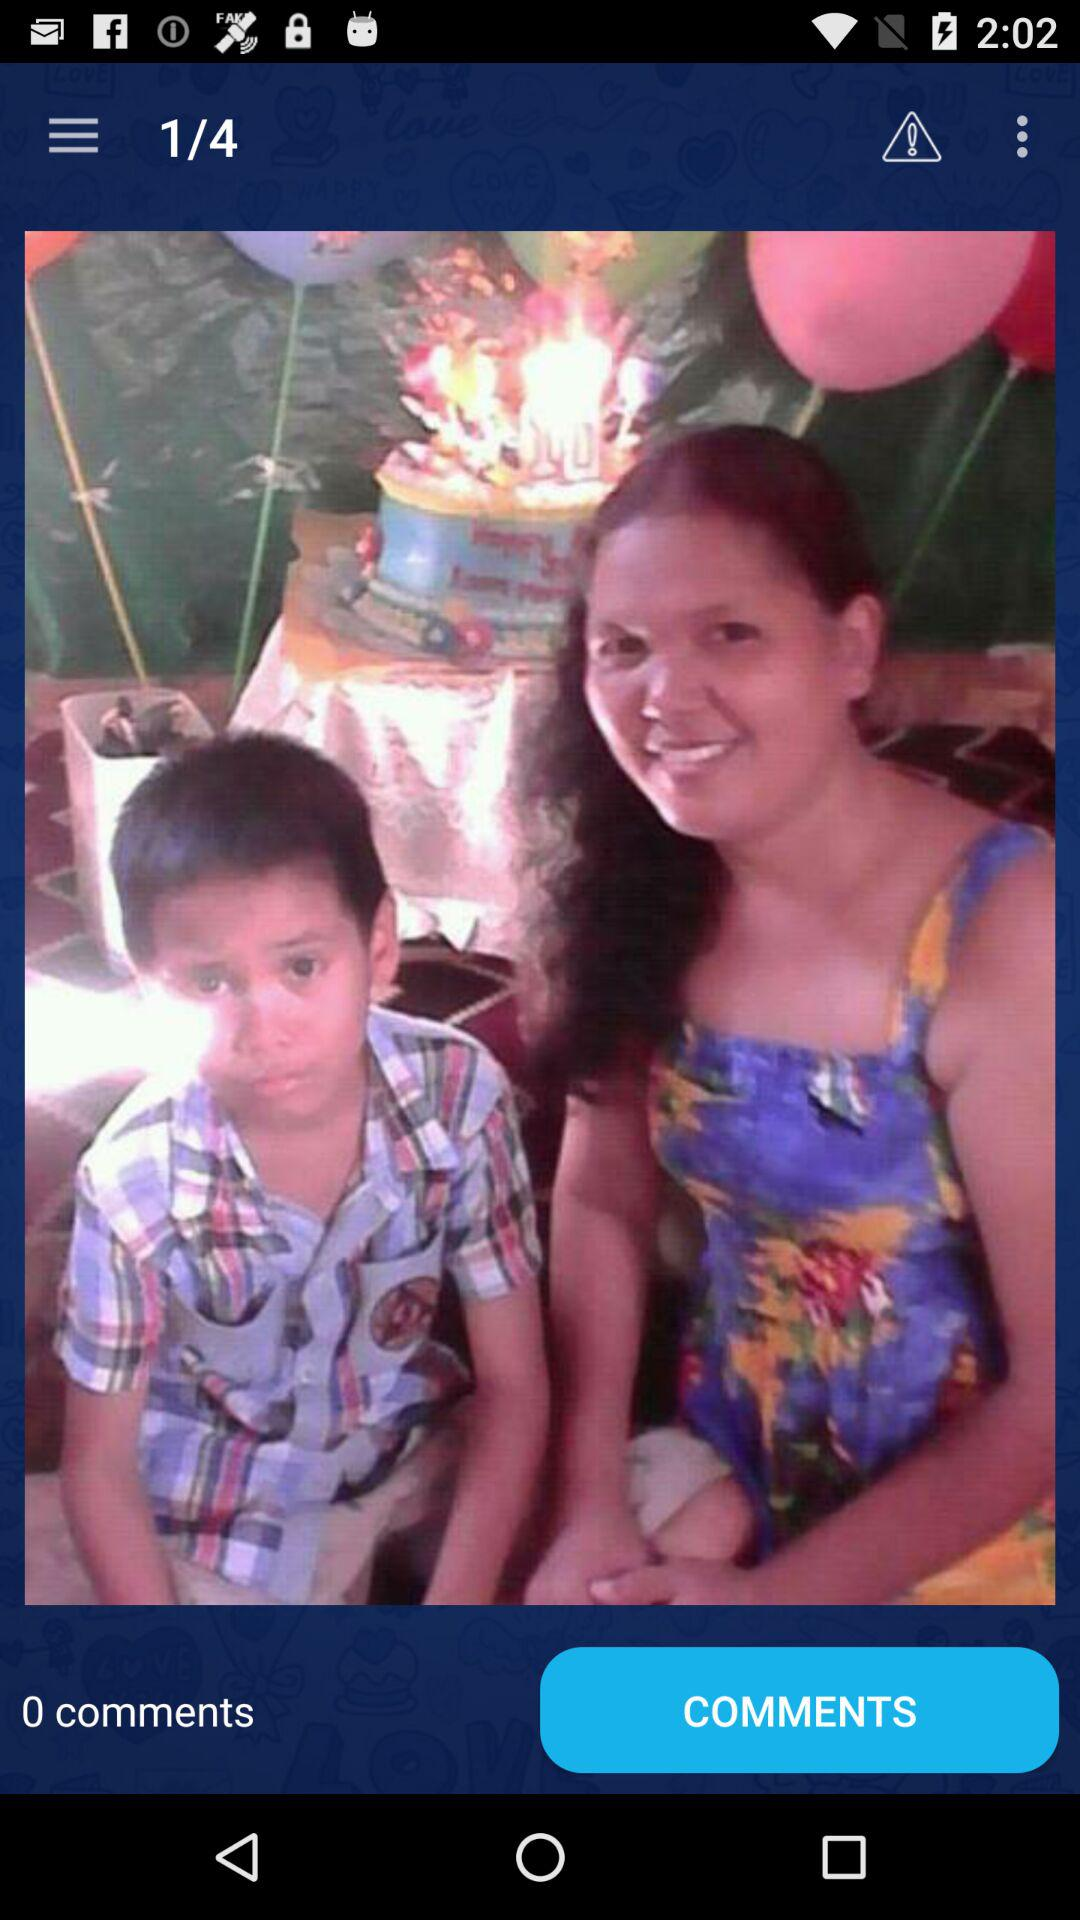How many images are there in total? There are 4 images in total. 